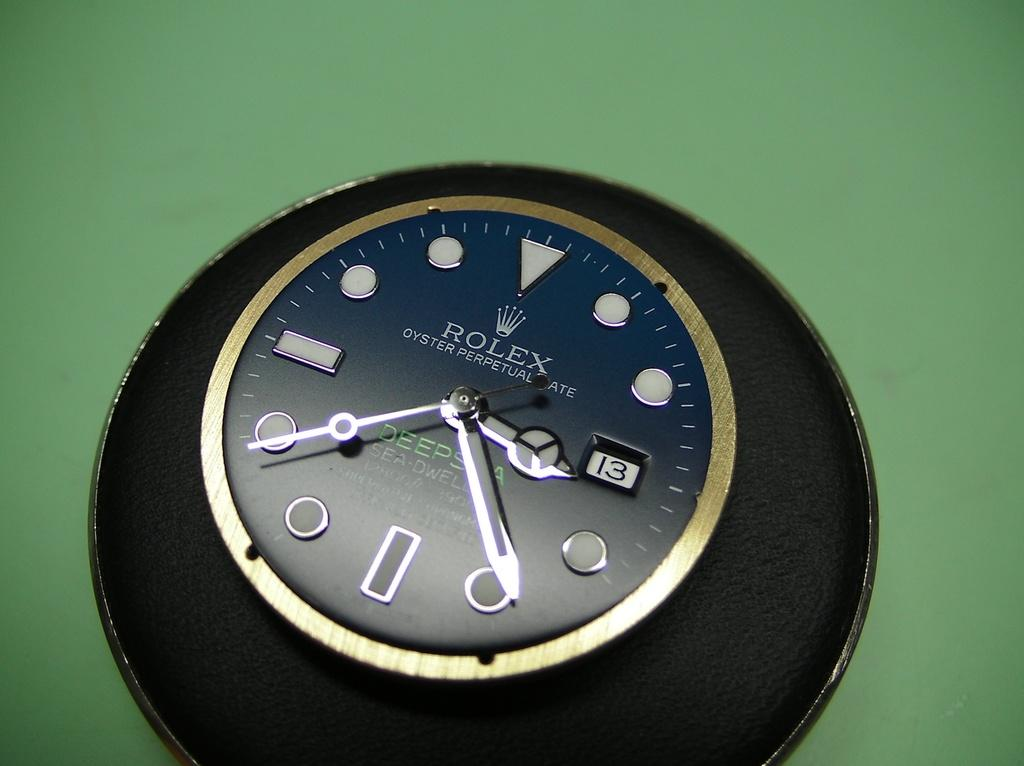<image>
Describe the image concisely. The face of a Rolex watch indicating the time as 3:19. 